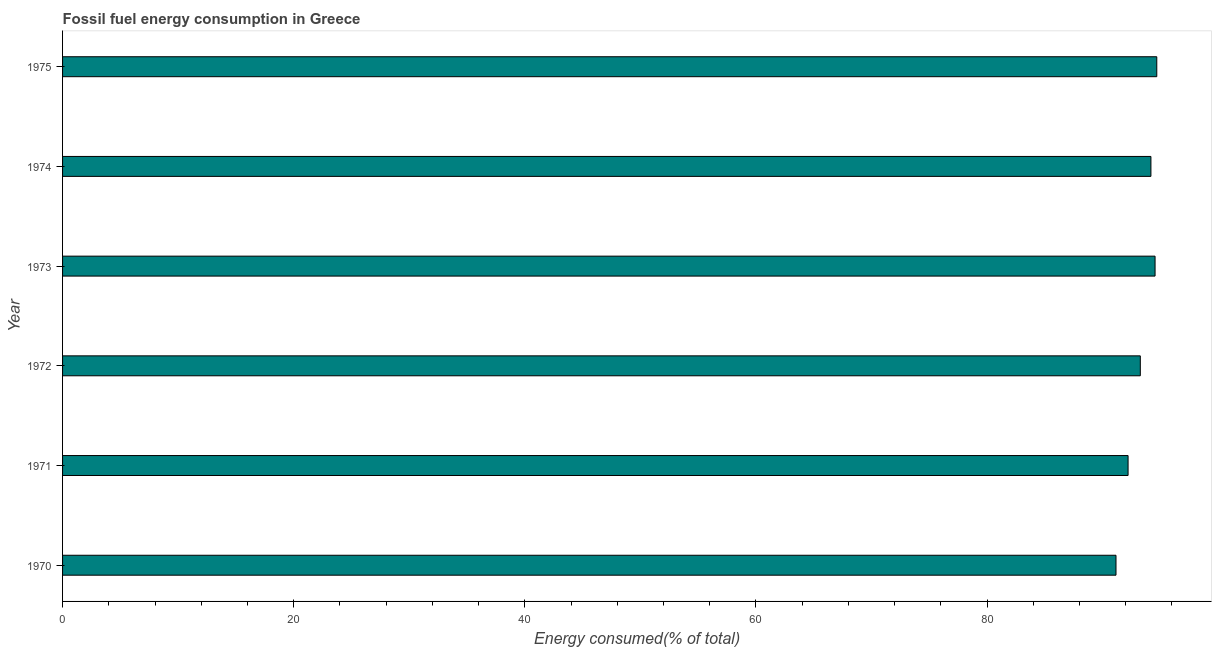Does the graph contain any zero values?
Your answer should be very brief. No. Does the graph contain grids?
Ensure brevity in your answer.  No. What is the title of the graph?
Offer a very short reply. Fossil fuel energy consumption in Greece. What is the label or title of the X-axis?
Provide a short and direct response. Energy consumed(% of total). What is the fossil fuel energy consumption in 1972?
Your answer should be compact. 93.26. Across all years, what is the maximum fossil fuel energy consumption?
Ensure brevity in your answer.  94.69. Across all years, what is the minimum fossil fuel energy consumption?
Make the answer very short. 91.16. In which year was the fossil fuel energy consumption maximum?
Your answer should be compact. 1975. What is the sum of the fossil fuel energy consumption?
Provide a short and direct response. 560.03. What is the difference between the fossil fuel energy consumption in 1972 and 1973?
Your answer should be very brief. -1.28. What is the average fossil fuel energy consumption per year?
Offer a very short reply. 93.34. What is the median fossil fuel energy consumption?
Ensure brevity in your answer.  93.72. Do a majority of the years between 1975 and 1974 (inclusive) have fossil fuel energy consumption greater than 64 %?
Offer a terse response. No. Is the fossil fuel energy consumption in 1970 less than that in 1972?
Give a very brief answer. Yes. What is the difference between the highest and the second highest fossil fuel energy consumption?
Offer a very short reply. 0.15. Is the sum of the fossil fuel energy consumption in 1970 and 1972 greater than the maximum fossil fuel energy consumption across all years?
Your answer should be compact. Yes. What is the difference between the highest and the lowest fossil fuel energy consumption?
Provide a short and direct response. 3.53. In how many years, is the fossil fuel energy consumption greater than the average fossil fuel energy consumption taken over all years?
Your answer should be very brief. 3. What is the difference between two consecutive major ticks on the X-axis?
Give a very brief answer. 20. What is the Energy consumed(% of total) of 1970?
Make the answer very short. 91.16. What is the Energy consumed(% of total) in 1971?
Provide a short and direct response. 92.2. What is the Energy consumed(% of total) in 1972?
Offer a terse response. 93.26. What is the Energy consumed(% of total) in 1973?
Provide a succinct answer. 94.54. What is the Energy consumed(% of total) of 1974?
Offer a terse response. 94.18. What is the Energy consumed(% of total) of 1975?
Offer a terse response. 94.69. What is the difference between the Energy consumed(% of total) in 1970 and 1971?
Give a very brief answer. -1.04. What is the difference between the Energy consumed(% of total) in 1970 and 1972?
Your response must be concise. -2.1. What is the difference between the Energy consumed(% of total) in 1970 and 1973?
Offer a terse response. -3.38. What is the difference between the Energy consumed(% of total) in 1970 and 1974?
Your answer should be very brief. -3.02. What is the difference between the Energy consumed(% of total) in 1970 and 1975?
Make the answer very short. -3.53. What is the difference between the Energy consumed(% of total) in 1971 and 1972?
Your answer should be compact. -1.06. What is the difference between the Energy consumed(% of total) in 1971 and 1973?
Offer a very short reply. -2.34. What is the difference between the Energy consumed(% of total) in 1971 and 1974?
Keep it short and to the point. -1.98. What is the difference between the Energy consumed(% of total) in 1971 and 1975?
Give a very brief answer. -2.48. What is the difference between the Energy consumed(% of total) in 1972 and 1973?
Provide a short and direct response. -1.28. What is the difference between the Energy consumed(% of total) in 1972 and 1974?
Offer a very short reply. -0.92. What is the difference between the Energy consumed(% of total) in 1972 and 1975?
Provide a succinct answer. -1.43. What is the difference between the Energy consumed(% of total) in 1973 and 1974?
Make the answer very short. 0.36. What is the difference between the Energy consumed(% of total) in 1973 and 1975?
Offer a very short reply. -0.15. What is the difference between the Energy consumed(% of total) in 1974 and 1975?
Offer a very short reply. -0.51. What is the ratio of the Energy consumed(% of total) in 1970 to that in 1973?
Provide a succinct answer. 0.96. What is the ratio of the Energy consumed(% of total) in 1970 to that in 1974?
Your response must be concise. 0.97. What is the ratio of the Energy consumed(% of total) in 1973 to that in 1974?
Offer a very short reply. 1. What is the ratio of the Energy consumed(% of total) in 1974 to that in 1975?
Your answer should be very brief. 0.99. 